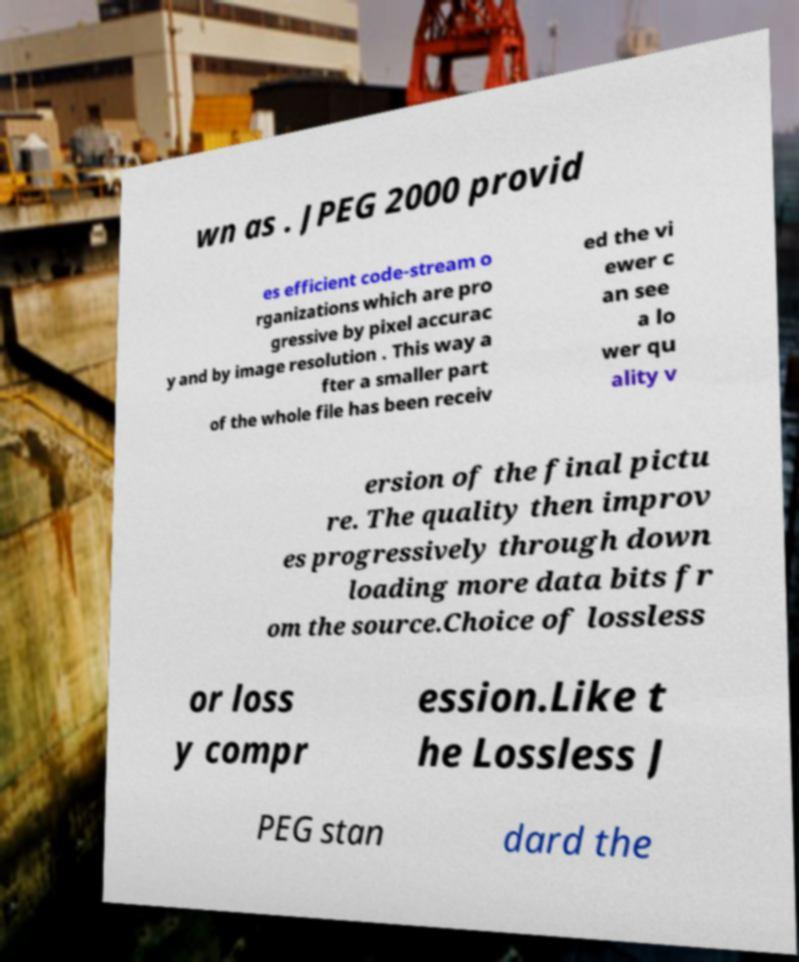For documentation purposes, I need the text within this image transcribed. Could you provide that? wn as . JPEG 2000 provid es efficient code-stream o rganizations which are pro gressive by pixel accurac y and by image resolution . This way a fter a smaller part of the whole file has been receiv ed the vi ewer c an see a lo wer qu ality v ersion of the final pictu re. The quality then improv es progressively through down loading more data bits fr om the source.Choice of lossless or loss y compr ession.Like t he Lossless J PEG stan dard the 